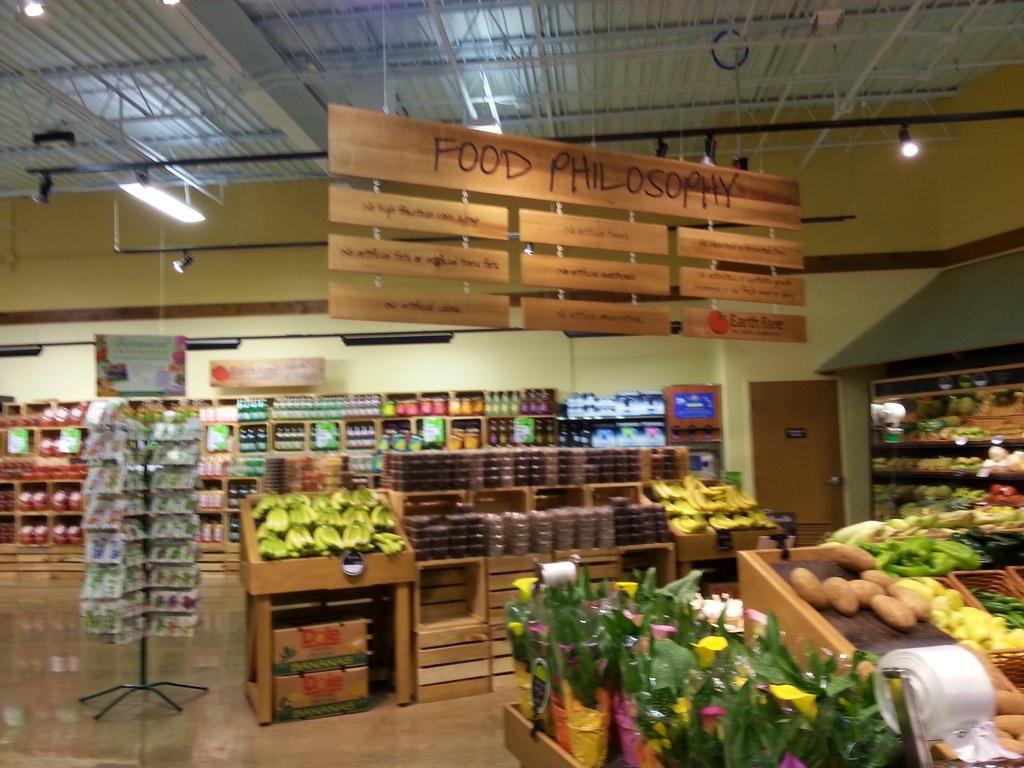How would you summarize this image in a sentence or two? In this image there is a store, in that store there are racks, in that racks there are few items, at the top there is a roof for that roof there a board hangs on that board there is some text and there are lights. 